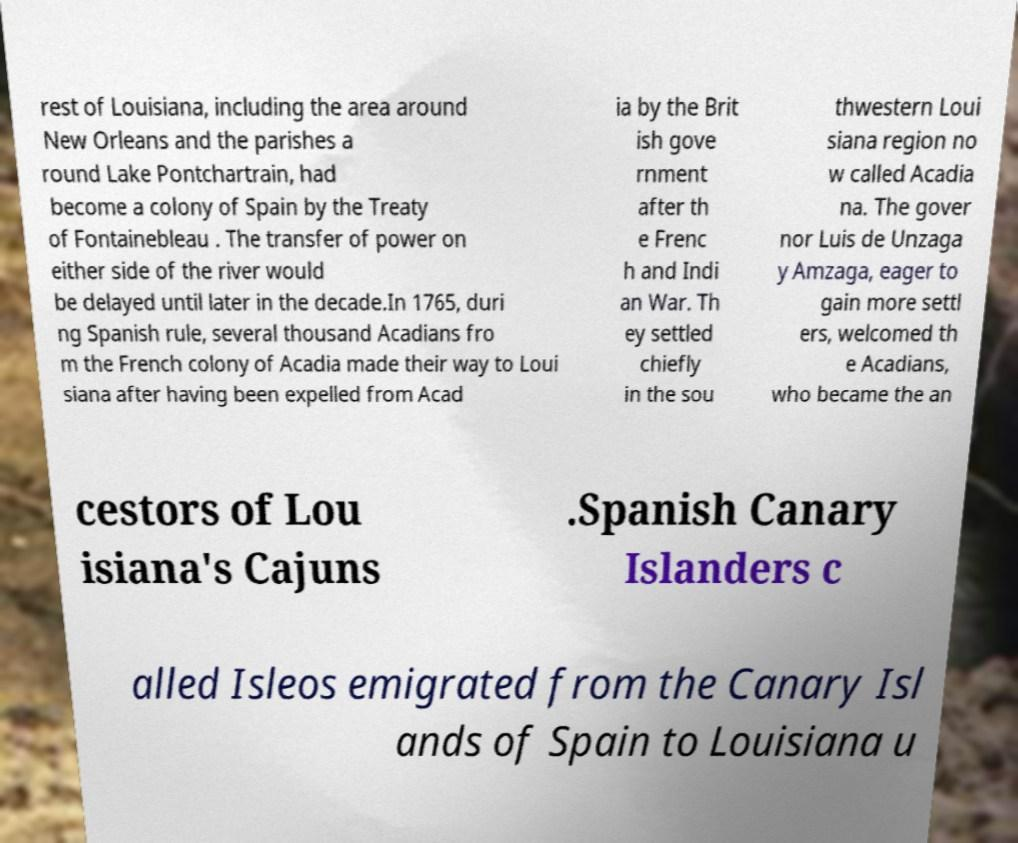Can you read and provide the text displayed in the image?This photo seems to have some interesting text. Can you extract and type it out for me? rest of Louisiana, including the area around New Orleans and the parishes a round Lake Pontchartrain, had become a colony of Spain by the Treaty of Fontainebleau . The transfer of power on either side of the river would be delayed until later in the decade.In 1765, duri ng Spanish rule, several thousand Acadians fro m the French colony of Acadia made their way to Loui siana after having been expelled from Acad ia by the Brit ish gove rnment after th e Frenc h and Indi an War. Th ey settled chiefly in the sou thwestern Loui siana region no w called Acadia na. The gover nor Luis de Unzaga y Amzaga, eager to gain more settl ers, welcomed th e Acadians, who became the an cestors of Lou isiana's Cajuns .Spanish Canary Islanders c alled Isleos emigrated from the Canary Isl ands of Spain to Louisiana u 